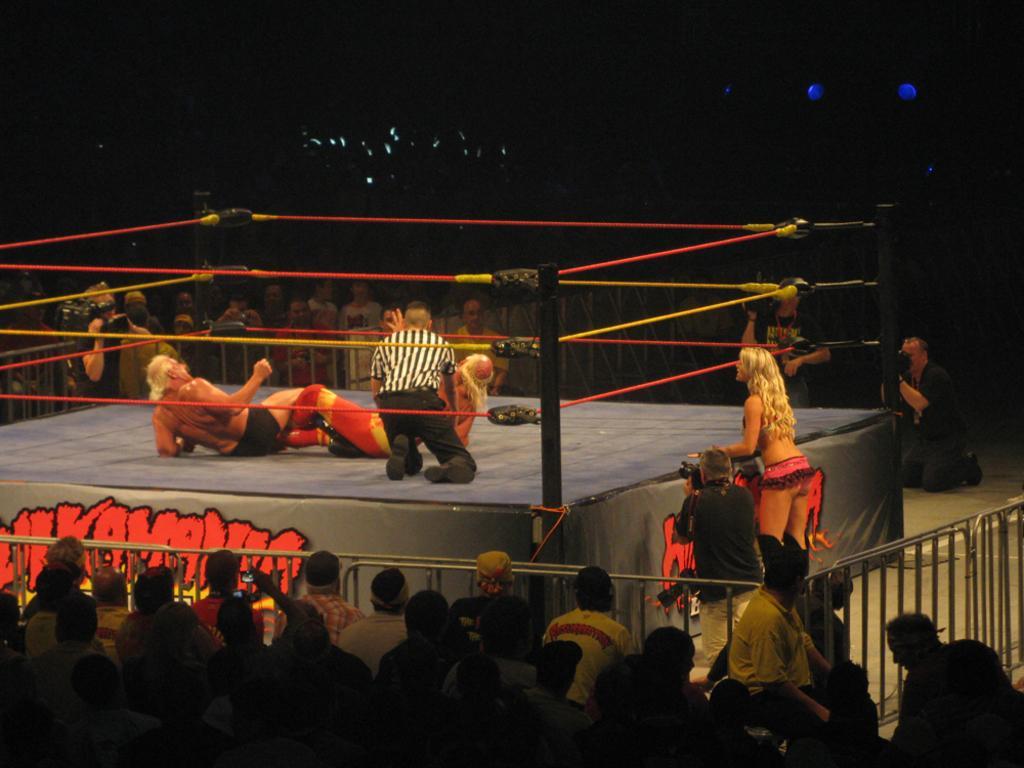How would you summarize this image in a sentence or two? In this image we can see a few people, among them, some people are on the stage, there are some ropes and railings, also we can see the background is dark. 